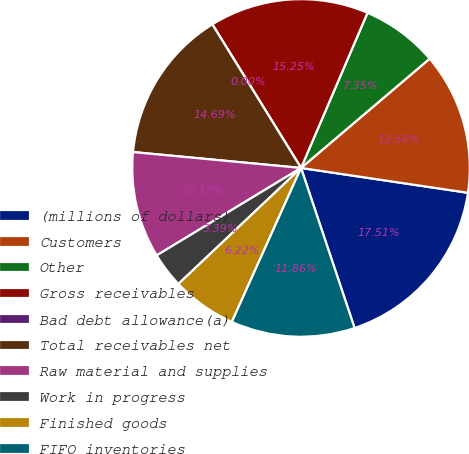Convert chart. <chart><loc_0><loc_0><loc_500><loc_500><pie_chart><fcel>(millions of dollars)<fcel>Customers<fcel>Other<fcel>Gross receivables<fcel>Bad debt allowance(a)<fcel>Total receivables net<fcel>Raw material and supplies<fcel>Work in progress<fcel>Finished goods<fcel>FIFO inventories<nl><fcel>17.51%<fcel>13.56%<fcel>7.35%<fcel>15.25%<fcel>0.0%<fcel>14.69%<fcel>10.17%<fcel>3.39%<fcel>6.22%<fcel>11.86%<nl></chart> 